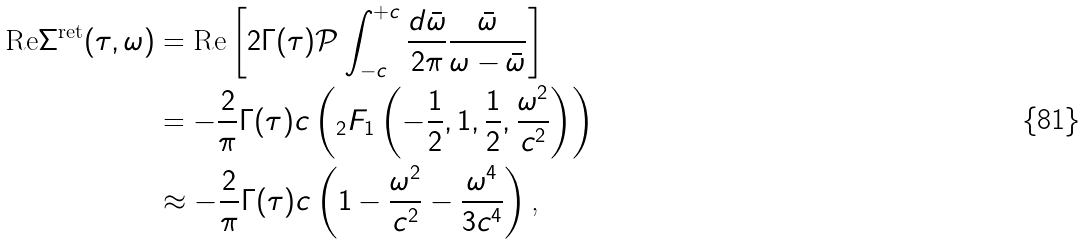Convert formula to latex. <formula><loc_0><loc_0><loc_500><loc_500>\text {Re} \Sigma ^ { \text {ret} } ( \tau , \omega ) & = \text {Re} \left [ 2 \Gamma ( \tau ) \mathcal { P } \int _ { - c } ^ { + c } \frac { d \bar { \omega } } { 2 \pi } \frac { \bar { \omega } } { \omega - \bar { \omega } } \right ] \\ & = - \frac { 2 } { \pi } \Gamma ( \tau ) c \left ( _ { 2 } F _ { 1 } \left ( - \frac { 1 } { 2 } , 1 , \frac { 1 } { 2 } , \frac { \omega ^ { 2 } } { c ^ { 2 } } \right ) \right ) \\ & \approx - \frac { 2 } { \pi } \Gamma ( \tau ) c \left ( 1 - \frac { \omega ^ { 2 } } { c ^ { 2 } } - \frac { \omega ^ { 4 } } { 3 c ^ { 4 } } \right ) \text {,}</formula> 